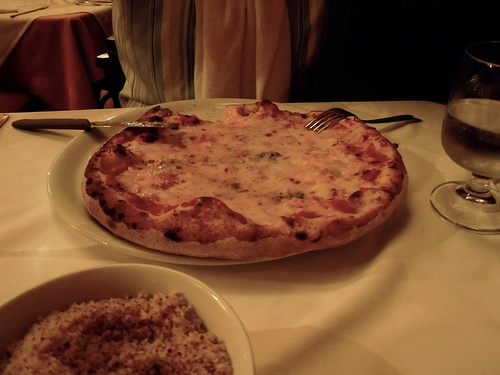Describe the objects in this image and their specific colors. I can see dining table in tan, maroon, and brown tones, pizza in tan, brown, maroon, and red tones, bowl in tan, maroon, and brown tones, people in tan, maroon, black, and gray tones, and wine glass in tan, black, olive, brown, and maroon tones in this image. 